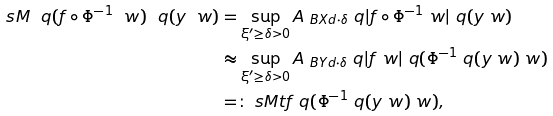<formula> <loc_0><loc_0><loc_500><loc_500>\ s M \ q ( f \circ \Phi ^ { - 1 } \ w ) \ q ( y \ w ) & = \sup _ { \xi ^ { \prime } \geq \delta > 0 } A _ { \ B { X } { d } { \cdot } { \delta } } \ q | f \circ \Phi ^ { - 1 } \ w | \ q ( y \ w ) \\ & \approx \sup _ { \xi ^ { \prime } \geq \delta > 0 } A _ { \ B { Y } { d } { \cdot } { \delta } } \ q | f \ w | \ q ( \Phi ^ { - 1 } \ q ( y \ w ) \ w ) \\ & = \colon \ s M t f \ q ( \Phi ^ { - 1 } \ q ( y \ w ) \ w ) ,</formula> 